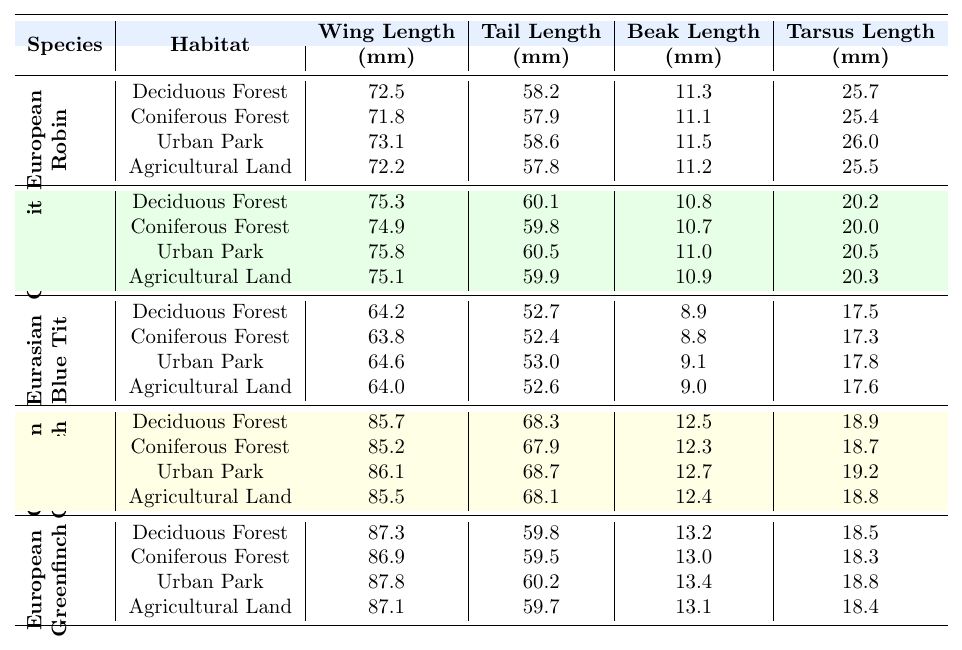What is the wing length of the Eurasian Blue Tit in Deciduous Forest habitat? The table displays the measurements of the Eurasian Blue Tit in the Deciduous Forest habitat, showing a wing length of 64.2 mm.
Answer: 64.2 mm Which bird species has the largest body mass in Agricultural Land habitat? Looking at the body mass measurements in the Agricultural Land habitat, the European Greenfinch has the largest body mass at 28.0 g, compared to others.
Answer: European Greenfinch What is the difference in wing length between the Great Tit and the Common Chaffinch in Urban Park habitat? The wing length of the Great Tit in Urban Park is 75.8 mm, and the Common Chaffinch is 86.1 mm. The difference is calculated as 86.1 mm - 75.8 mm = 10.3 mm.
Answer: 10.3 mm Is the tail length of the European Robin longer in Urban Park or Agricultural Land? The tail length of the European Robin in Urban Park is 58.6 mm, while in Agricultural Land, it is 57.8 mm. Since 58.6 mm is greater than 57.8 mm, it is longer in Urban Park.
Answer: Yes What is the average beak length of the Eurasian Blue Tit across all habitats? The beak lengths in various habitats for the Eurasian Blue Tit are 8.9 mm (Deciduous Forest), 8.8 mm (Coniferous Forest), 9.1 mm (Urban Park), and 9.0 mm (Agricultural Land). Summing these gives 35.8 mm, and dividing by 4 offers an average of 8.95 mm.
Answer: 8.95 mm In which habitat does the Common Chaffinch show the largest tail length? The tail lengths for the Common Chaffinch are 68.3 mm (Deciduous Forest), 67.9 mm (Coniferous Forest), 68.7 mm (Urban Park), and 68.1 mm (Agricultural Land). Since 68.7 mm in Urban Park is the highest, that's the habitat where it shows the largest tail length.
Answer: Urban Park Which species has the shortest tarsus length in Deciduous Forest? The tarsus lengths for each species in Deciduous Forest are compared: European Robin (25.7 mm), Great Tit (20.2 mm), Eurasian Blue Tit (17.5 mm), Common Chaffinch (18.9 mm), and European Greenfinch (18.5 mm). The Eurasian Blue Tit has the shortest tarsus length at 17.5 mm.
Answer: Eurasian Blue Tit What is the median wing length of the European Greenfinch across all habitats? The wing lengths of the European Greenfinch are 87.3 mm (Deciduous Forest), 86.9 mm (Coniferous Forest), 87.8 mm (Urban Park), and 87.1 mm (Agricultural Land). Sorting these values gives 86.9, 87.1, 87.3, and 87.8 mm. The middle two values are 87.1 mm and 87.3 mm, so the median is (87.1 + 87.3)/2 = 87.2 mm.
Answer: 87.2 mm How does the body mass of the Great Tit compare to that of the Eurasian Blue Tit in Urban Park? In Urban Park, the Great Tit has a body mass of 19.0 g, while the Eurasian Blue Tit has a body mass of 11.5 g. Comparing these shows that the Great Tit is heavier by 19.0 g - 11.5 g = 7.5 g.
Answer: 7.5 g heavier Which species has a shorter tail length: the European Greenfinch or the Great Tit in Coniferous Forest? The tail lengths are 59.5 mm for the European Greenfinch and 59.8 mm for the Great Tit in Coniferous Forest. Since 59.5 mm is shorter than 59.8 mm, the European Greenfinch has the shorter tail length.
Answer: European Greenfinch 